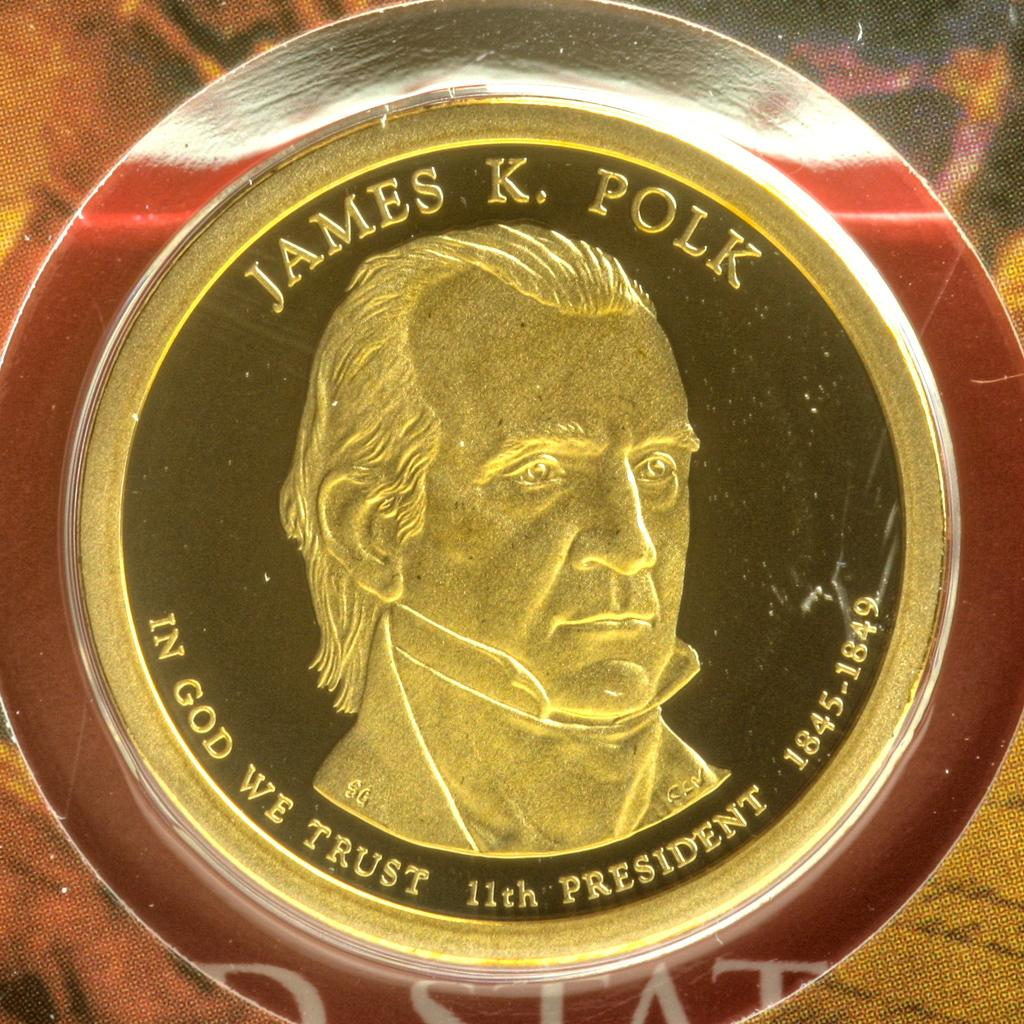What object is the main focus of the image? There is a coin in the image. What colors can be seen on the coin? The coin has black and gold colors. What is depicted on the coin? There is a person's face on the coin. What type of garden can be seen in the background of the image? There is no garden present in the image; it only features a coin with a person's face on it. How does the love between the two people in the image manifest itself? There are no people or any indication of love in the image, as it only features a coin. 